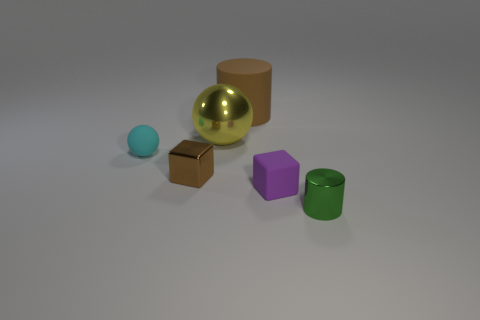There is a cylinder that is on the left side of the purple cube; is it the same color as the small shiny cube? Yes, the cylinder on the left side of the purple cube appears to have the same green hue as the small shiny cube. 